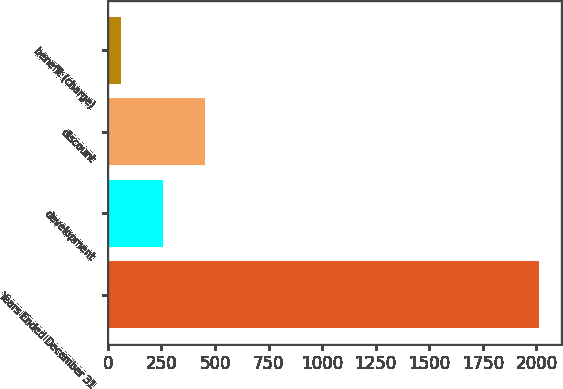Convert chart. <chart><loc_0><loc_0><loc_500><loc_500><bar_chart><fcel>Years Ended December 31<fcel>development<fcel>discount<fcel>benefit (charge)<nl><fcel>2012<fcel>257.9<fcel>452.8<fcel>63<nl></chart> 